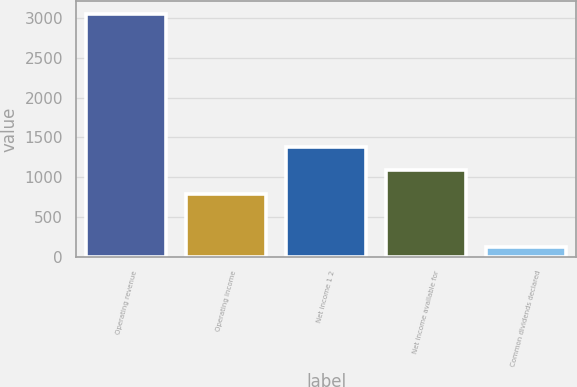Convert chart to OTSL. <chart><loc_0><loc_0><loc_500><loc_500><bar_chart><fcel>Operating revenue<fcel>Operating income<fcel>Net income 1 2<fcel>Net income available for<fcel>Common dividends declared<nl><fcel>3057<fcel>792<fcel>1379.4<fcel>1085.7<fcel>120<nl></chart> 